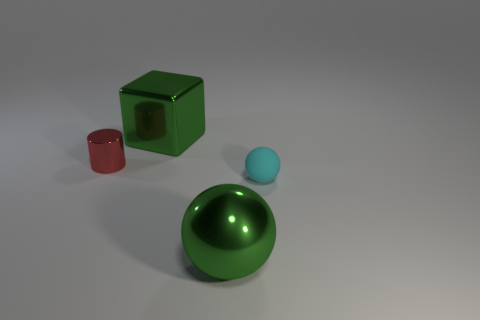What color is the large thing left of the green metallic ball?
Ensure brevity in your answer.  Green. There is a large thing that is the same color as the large metal sphere; what is it made of?
Keep it short and to the point. Metal. There is a block; are there any big shiny things left of it?
Give a very brief answer. No. Is the number of large cyan cubes greater than the number of green cubes?
Your answer should be compact. No. There is a big metallic object that is behind the red thing that is left of the green thing that is in front of the small matte ball; what color is it?
Give a very brief answer. Green. There is a ball that is the same material as the red cylinder; what is its color?
Provide a short and direct response. Green. Are there any other things that are the same size as the cyan ball?
Your response must be concise. Yes. What number of objects are large green metallic objects to the left of the big ball or big green objects in front of the cylinder?
Your answer should be compact. 2. Do the green metallic object in front of the large green cube and the metal thing behind the red metal cylinder have the same size?
Provide a succinct answer. Yes. What color is the other large metallic object that is the same shape as the cyan object?
Provide a short and direct response. Green. 